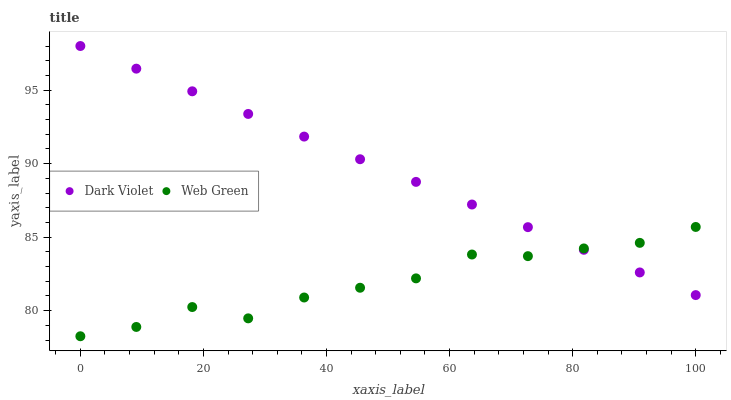Does Web Green have the minimum area under the curve?
Answer yes or no. Yes. Does Dark Violet have the maximum area under the curve?
Answer yes or no. Yes. Does Dark Violet have the minimum area under the curve?
Answer yes or no. No. Is Dark Violet the smoothest?
Answer yes or no. Yes. Is Web Green the roughest?
Answer yes or no. Yes. Is Dark Violet the roughest?
Answer yes or no. No. Does Web Green have the lowest value?
Answer yes or no. Yes. Does Dark Violet have the lowest value?
Answer yes or no. No. Does Dark Violet have the highest value?
Answer yes or no. Yes. Does Web Green intersect Dark Violet?
Answer yes or no. Yes. Is Web Green less than Dark Violet?
Answer yes or no. No. Is Web Green greater than Dark Violet?
Answer yes or no. No. 